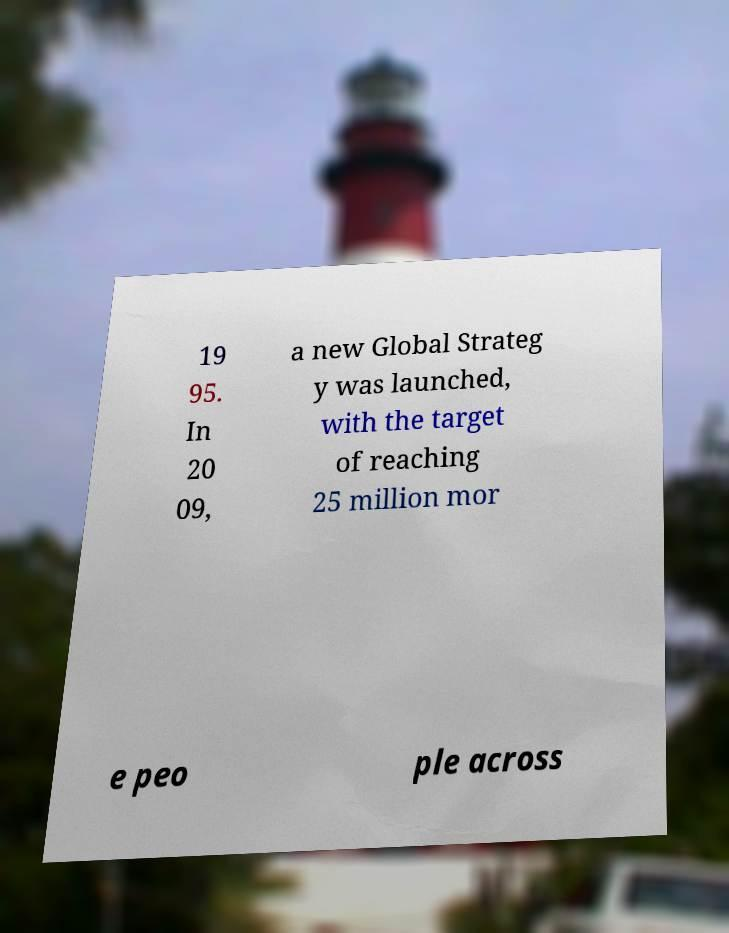There's text embedded in this image that I need extracted. Can you transcribe it verbatim? 19 95. In 20 09, a new Global Strateg y was launched, with the target of reaching 25 million mor e peo ple across 